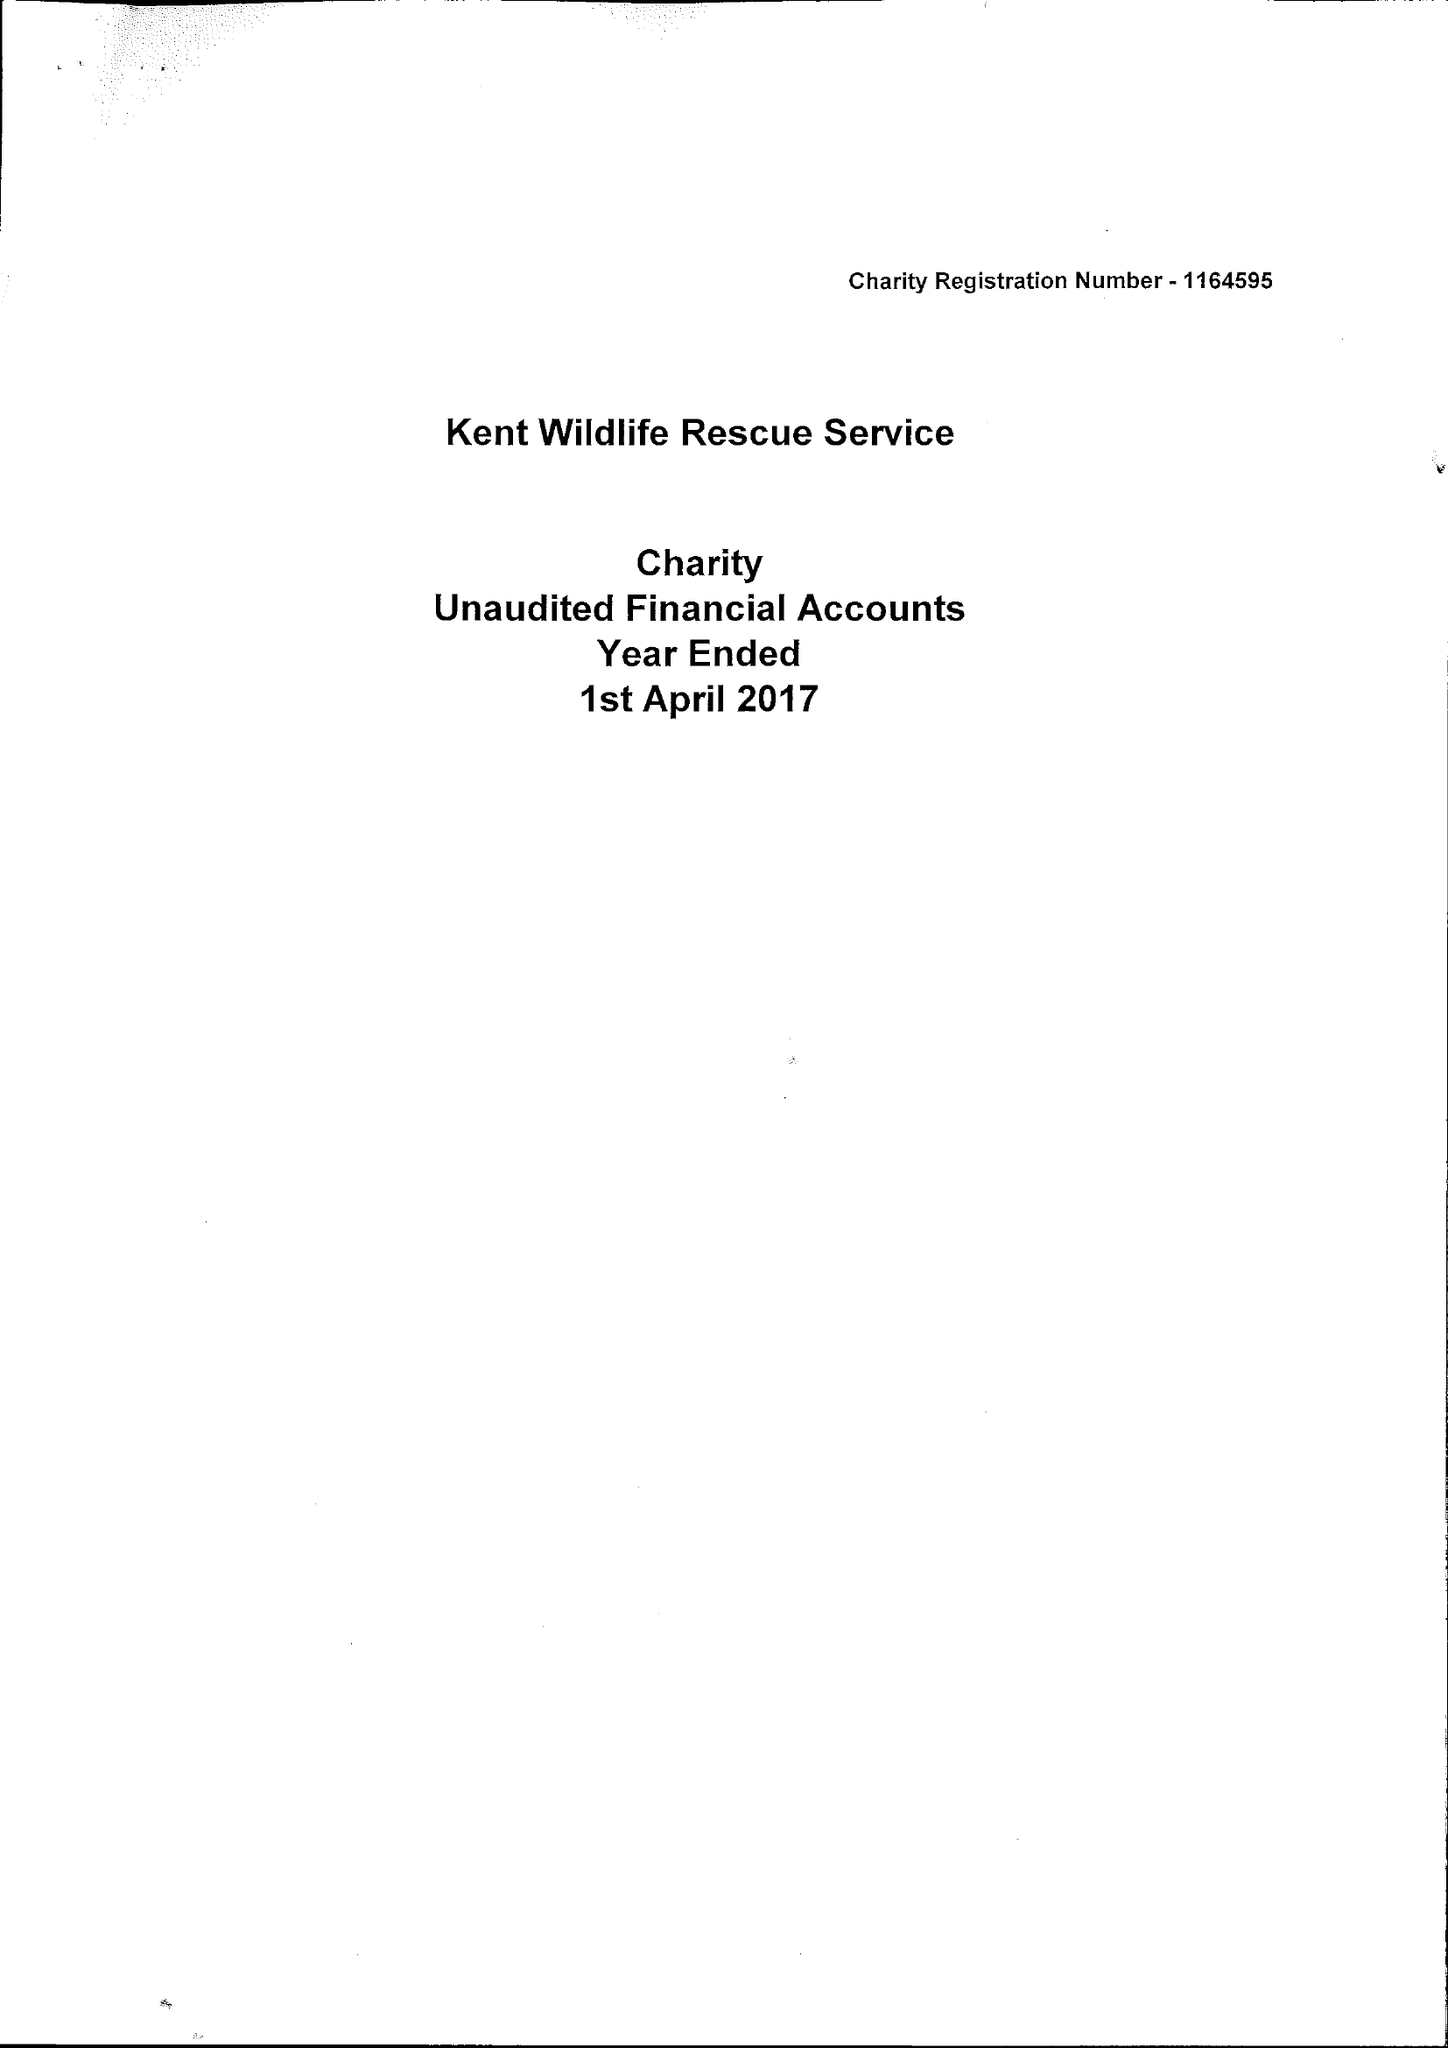What is the value for the charity_number?
Answer the question using a single word or phrase. 1164595 